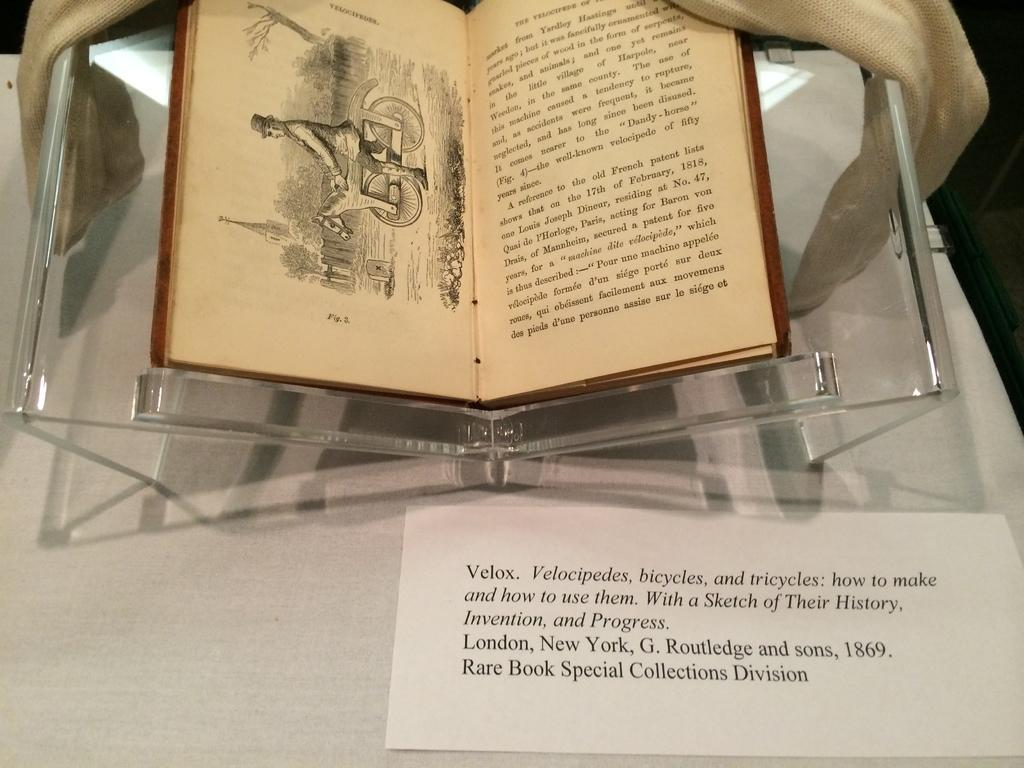<image>
Write a terse but informative summary of the picture. A copy of a rare book from 1869 called Velox displayed in a case. 